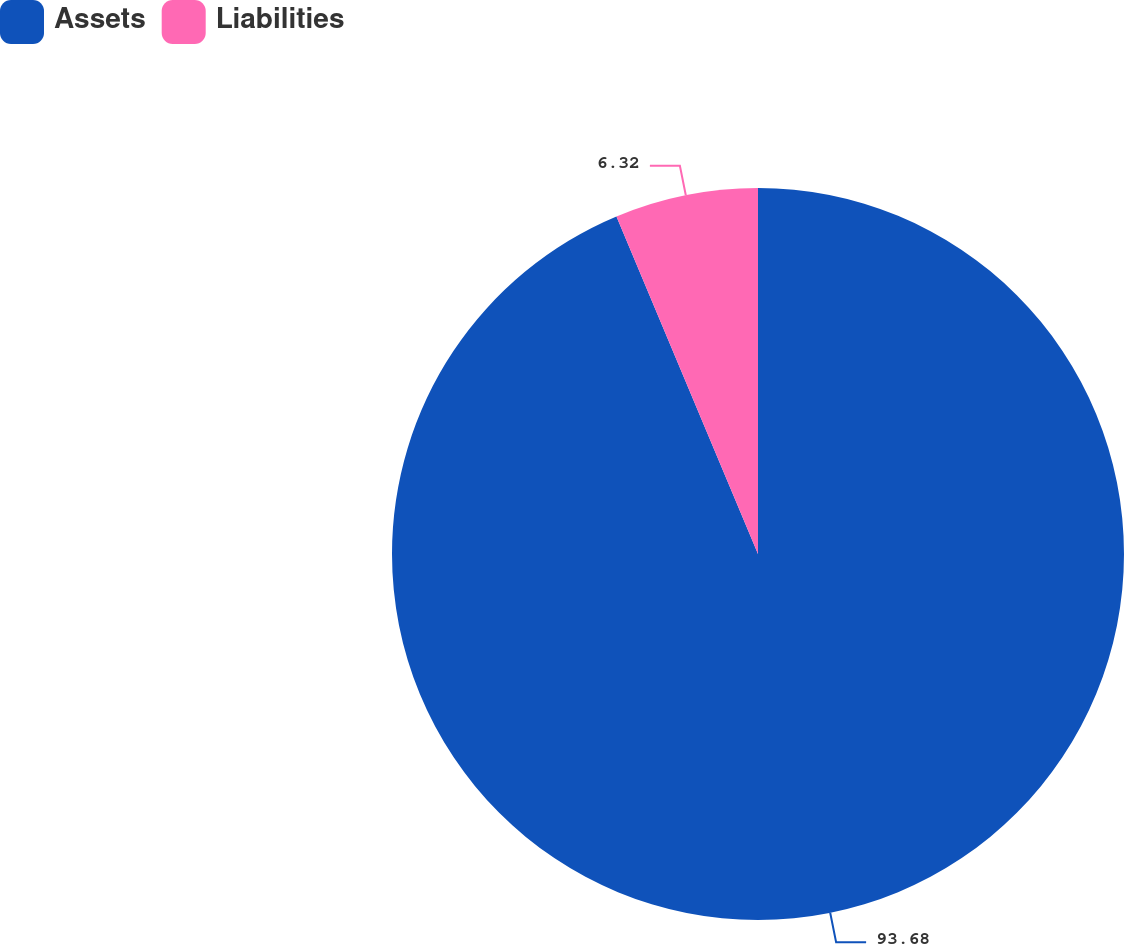Convert chart to OTSL. <chart><loc_0><loc_0><loc_500><loc_500><pie_chart><fcel>Assets<fcel>Liabilities<nl><fcel>93.68%<fcel>6.32%<nl></chart> 